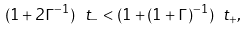<formula> <loc_0><loc_0><loc_500><loc_500>( 1 + 2 \Gamma ^ { - 1 } ) \ t _ { - } < ( 1 + ( 1 + \Gamma ) ^ { - 1 } ) \ t _ { + } ,</formula> 